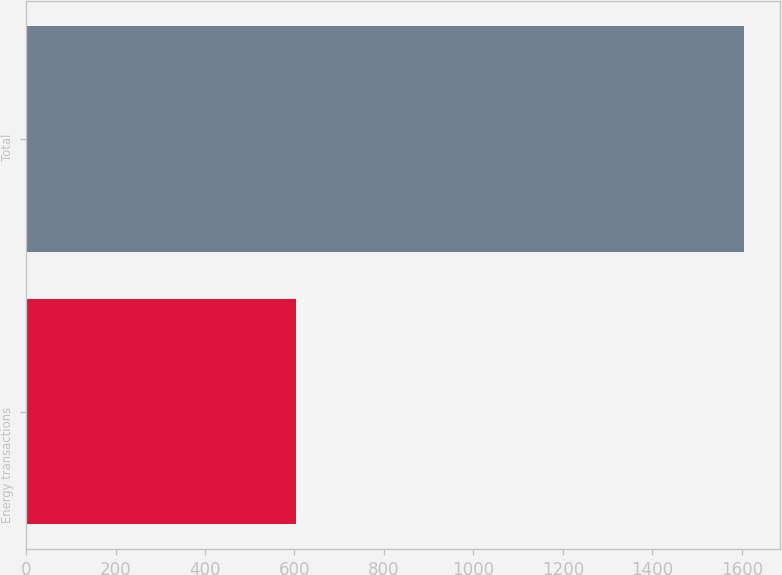<chart> <loc_0><loc_0><loc_500><loc_500><bar_chart><fcel>Energy transactions<fcel>Total<nl><fcel>603<fcel>1605<nl></chart> 